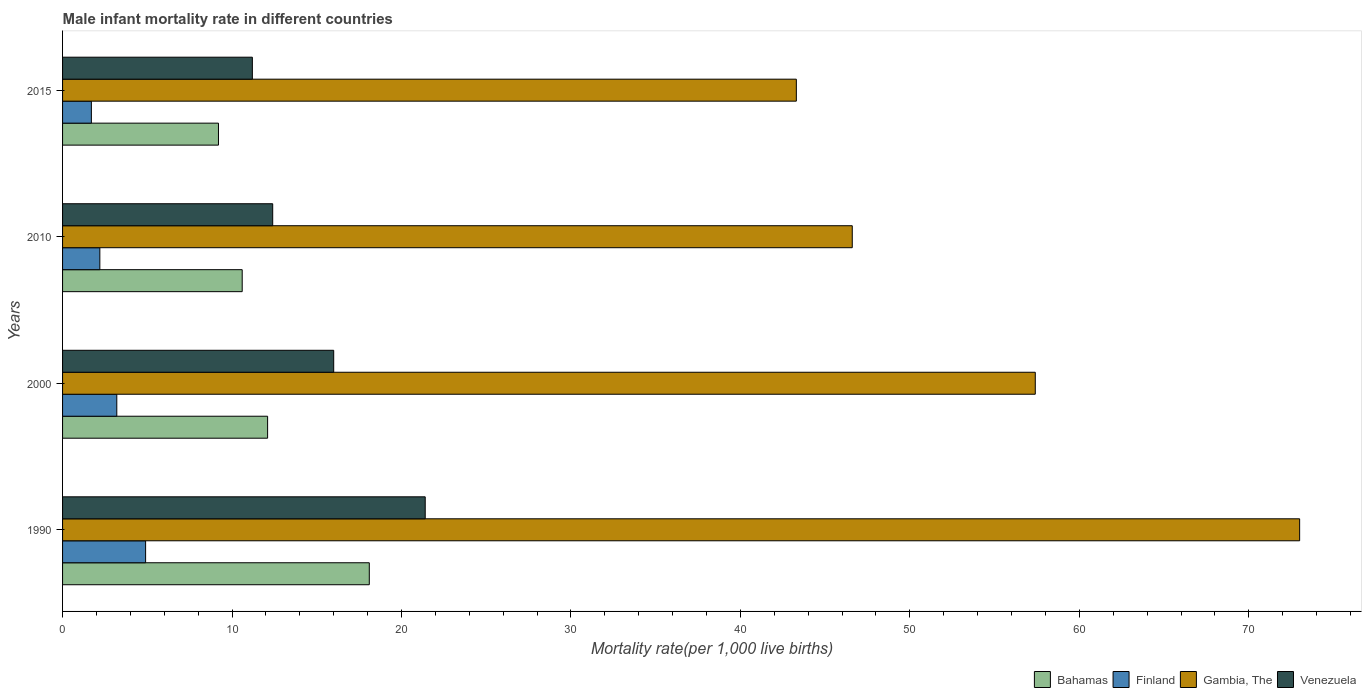Are the number of bars per tick equal to the number of legend labels?
Ensure brevity in your answer.  Yes. How many bars are there on the 2nd tick from the top?
Provide a succinct answer. 4. What is the male infant mortality rate in Gambia, The in 2010?
Provide a short and direct response. 46.6. Across all years, what is the maximum male infant mortality rate in Venezuela?
Provide a succinct answer. 21.4. Across all years, what is the minimum male infant mortality rate in Bahamas?
Offer a very short reply. 9.2. In which year was the male infant mortality rate in Gambia, The minimum?
Keep it short and to the point. 2015. What is the difference between the male infant mortality rate in Bahamas in 2010 and that in 2015?
Ensure brevity in your answer.  1.4. What is the difference between the male infant mortality rate in Bahamas in 1990 and the male infant mortality rate in Gambia, The in 2000?
Give a very brief answer. -39.3. What is the average male infant mortality rate in Gambia, The per year?
Give a very brief answer. 55.08. In the year 2010, what is the difference between the male infant mortality rate in Gambia, The and male infant mortality rate in Finland?
Offer a very short reply. 44.4. In how many years, is the male infant mortality rate in Bahamas greater than 60 ?
Offer a terse response. 0. What is the ratio of the male infant mortality rate in Bahamas in 2000 to that in 2015?
Keep it short and to the point. 1.32. Is the difference between the male infant mortality rate in Gambia, The in 2010 and 2015 greater than the difference between the male infant mortality rate in Finland in 2010 and 2015?
Provide a short and direct response. Yes. What is the difference between the highest and the second highest male infant mortality rate in Venezuela?
Make the answer very short. 5.4. Is it the case that in every year, the sum of the male infant mortality rate in Finland and male infant mortality rate in Bahamas is greater than the sum of male infant mortality rate in Gambia, The and male infant mortality rate in Venezuela?
Your answer should be very brief. Yes. What does the 3rd bar from the top in 2000 represents?
Your response must be concise. Finland. What does the 1st bar from the bottom in 2015 represents?
Offer a terse response. Bahamas. Is it the case that in every year, the sum of the male infant mortality rate in Gambia, The and male infant mortality rate in Finland is greater than the male infant mortality rate in Bahamas?
Keep it short and to the point. Yes. How many bars are there?
Make the answer very short. 16. What is the difference between two consecutive major ticks on the X-axis?
Your answer should be compact. 10. Are the values on the major ticks of X-axis written in scientific E-notation?
Your answer should be compact. No. Where does the legend appear in the graph?
Provide a succinct answer. Bottom right. How many legend labels are there?
Your answer should be very brief. 4. What is the title of the graph?
Offer a terse response. Male infant mortality rate in different countries. What is the label or title of the X-axis?
Your answer should be very brief. Mortality rate(per 1,0 live births). What is the Mortality rate(per 1,000 live births) of Bahamas in 1990?
Offer a very short reply. 18.1. What is the Mortality rate(per 1,000 live births) of Venezuela in 1990?
Your answer should be compact. 21.4. What is the Mortality rate(per 1,000 live births) in Finland in 2000?
Offer a terse response. 3.2. What is the Mortality rate(per 1,000 live births) of Gambia, The in 2000?
Provide a succinct answer. 57.4. What is the Mortality rate(per 1,000 live births) of Venezuela in 2000?
Your answer should be very brief. 16. What is the Mortality rate(per 1,000 live births) of Gambia, The in 2010?
Keep it short and to the point. 46.6. What is the Mortality rate(per 1,000 live births) of Venezuela in 2010?
Provide a short and direct response. 12.4. What is the Mortality rate(per 1,000 live births) in Bahamas in 2015?
Provide a short and direct response. 9.2. What is the Mortality rate(per 1,000 live births) of Finland in 2015?
Offer a very short reply. 1.7. What is the Mortality rate(per 1,000 live births) in Gambia, The in 2015?
Give a very brief answer. 43.3. What is the Mortality rate(per 1,000 live births) in Venezuela in 2015?
Offer a very short reply. 11.2. Across all years, what is the maximum Mortality rate(per 1,000 live births) of Bahamas?
Your answer should be very brief. 18.1. Across all years, what is the maximum Mortality rate(per 1,000 live births) of Gambia, The?
Provide a succinct answer. 73. Across all years, what is the maximum Mortality rate(per 1,000 live births) in Venezuela?
Your response must be concise. 21.4. Across all years, what is the minimum Mortality rate(per 1,000 live births) in Finland?
Provide a short and direct response. 1.7. Across all years, what is the minimum Mortality rate(per 1,000 live births) of Gambia, The?
Provide a short and direct response. 43.3. What is the total Mortality rate(per 1,000 live births) of Bahamas in the graph?
Provide a succinct answer. 50. What is the total Mortality rate(per 1,000 live births) in Gambia, The in the graph?
Give a very brief answer. 220.3. What is the difference between the Mortality rate(per 1,000 live births) of Finland in 1990 and that in 2000?
Your response must be concise. 1.7. What is the difference between the Mortality rate(per 1,000 live births) of Gambia, The in 1990 and that in 2000?
Provide a short and direct response. 15.6. What is the difference between the Mortality rate(per 1,000 live births) in Bahamas in 1990 and that in 2010?
Provide a short and direct response. 7.5. What is the difference between the Mortality rate(per 1,000 live births) of Gambia, The in 1990 and that in 2010?
Offer a terse response. 26.4. What is the difference between the Mortality rate(per 1,000 live births) of Finland in 1990 and that in 2015?
Ensure brevity in your answer.  3.2. What is the difference between the Mortality rate(per 1,000 live births) of Gambia, The in 1990 and that in 2015?
Make the answer very short. 29.7. What is the difference between the Mortality rate(per 1,000 live births) of Bahamas in 2000 and that in 2010?
Provide a succinct answer. 1.5. What is the difference between the Mortality rate(per 1,000 live births) in Finland in 2000 and that in 2010?
Offer a terse response. 1. What is the difference between the Mortality rate(per 1,000 live births) of Gambia, The in 2000 and that in 2010?
Offer a terse response. 10.8. What is the difference between the Mortality rate(per 1,000 live births) in Bahamas in 2000 and that in 2015?
Ensure brevity in your answer.  2.9. What is the difference between the Mortality rate(per 1,000 live births) of Finland in 2000 and that in 2015?
Ensure brevity in your answer.  1.5. What is the difference between the Mortality rate(per 1,000 live births) in Gambia, The in 2000 and that in 2015?
Your response must be concise. 14.1. What is the difference between the Mortality rate(per 1,000 live births) in Bahamas in 2010 and that in 2015?
Offer a very short reply. 1.4. What is the difference between the Mortality rate(per 1,000 live births) in Gambia, The in 2010 and that in 2015?
Make the answer very short. 3.3. What is the difference between the Mortality rate(per 1,000 live births) of Bahamas in 1990 and the Mortality rate(per 1,000 live births) of Gambia, The in 2000?
Offer a terse response. -39.3. What is the difference between the Mortality rate(per 1,000 live births) of Bahamas in 1990 and the Mortality rate(per 1,000 live births) of Venezuela in 2000?
Keep it short and to the point. 2.1. What is the difference between the Mortality rate(per 1,000 live births) of Finland in 1990 and the Mortality rate(per 1,000 live births) of Gambia, The in 2000?
Offer a very short reply. -52.5. What is the difference between the Mortality rate(per 1,000 live births) in Bahamas in 1990 and the Mortality rate(per 1,000 live births) in Gambia, The in 2010?
Provide a succinct answer. -28.5. What is the difference between the Mortality rate(per 1,000 live births) of Bahamas in 1990 and the Mortality rate(per 1,000 live births) of Venezuela in 2010?
Provide a short and direct response. 5.7. What is the difference between the Mortality rate(per 1,000 live births) of Finland in 1990 and the Mortality rate(per 1,000 live births) of Gambia, The in 2010?
Ensure brevity in your answer.  -41.7. What is the difference between the Mortality rate(per 1,000 live births) of Gambia, The in 1990 and the Mortality rate(per 1,000 live births) of Venezuela in 2010?
Provide a succinct answer. 60.6. What is the difference between the Mortality rate(per 1,000 live births) in Bahamas in 1990 and the Mortality rate(per 1,000 live births) in Gambia, The in 2015?
Give a very brief answer. -25.2. What is the difference between the Mortality rate(per 1,000 live births) in Finland in 1990 and the Mortality rate(per 1,000 live births) in Gambia, The in 2015?
Your response must be concise. -38.4. What is the difference between the Mortality rate(per 1,000 live births) of Finland in 1990 and the Mortality rate(per 1,000 live births) of Venezuela in 2015?
Your answer should be compact. -6.3. What is the difference between the Mortality rate(per 1,000 live births) of Gambia, The in 1990 and the Mortality rate(per 1,000 live births) of Venezuela in 2015?
Give a very brief answer. 61.8. What is the difference between the Mortality rate(per 1,000 live births) in Bahamas in 2000 and the Mortality rate(per 1,000 live births) in Finland in 2010?
Offer a very short reply. 9.9. What is the difference between the Mortality rate(per 1,000 live births) of Bahamas in 2000 and the Mortality rate(per 1,000 live births) of Gambia, The in 2010?
Offer a very short reply. -34.5. What is the difference between the Mortality rate(per 1,000 live births) of Bahamas in 2000 and the Mortality rate(per 1,000 live births) of Venezuela in 2010?
Give a very brief answer. -0.3. What is the difference between the Mortality rate(per 1,000 live births) in Finland in 2000 and the Mortality rate(per 1,000 live births) in Gambia, The in 2010?
Offer a very short reply. -43.4. What is the difference between the Mortality rate(per 1,000 live births) in Bahamas in 2000 and the Mortality rate(per 1,000 live births) in Gambia, The in 2015?
Your response must be concise. -31.2. What is the difference between the Mortality rate(per 1,000 live births) in Bahamas in 2000 and the Mortality rate(per 1,000 live births) in Venezuela in 2015?
Offer a terse response. 0.9. What is the difference between the Mortality rate(per 1,000 live births) in Finland in 2000 and the Mortality rate(per 1,000 live births) in Gambia, The in 2015?
Provide a short and direct response. -40.1. What is the difference between the Mortality rate(per 1,000 live births) of Finland in 2000 and the Mortality rate(per 1,000 live births) of Venezuela in 2015?
Give a very brief answer. -8. What is the difference between the Mortality rate(per 1,000 live births) in Gambia, The in 2000 and the Mortality rate(per 1,000 live births) in Venezuela in 2015?
Ensure brevity in your answer.  46.2. What is the difference between the Mortality rate(per 1,000 live births) of Bahamas in 2010 and the Mortality rate(per 1,000 live births) of Finland in 2015?
Your response must be concise. 8.9. What is the difference between the Mortality rate(per 1,000 live births) of Bahamas in 2010 and the Mortality rate(per 1,000 live births) of Gambia, The in 2015?
Give a very brief answer. -32.7. What is the difference between the Mortality rate(per 1,000 live births) in Finland in 2010 and the Mortality rate(per 1,000 live births) in Gambia, The in 2015?
Your answer should be compact. -41.1. What is the difference between the Mortality rate(per 1,000 live births) in Gambia, The in 2010 and the Mortality rate(per 1,000 live births) in Venezuela in 2015?
Make the answer very short. 35.4. What is the average Mortality rate(per 1,000 live births) of Bahamas per year?
Keep it short and to the point. 12.5. What is the average Mortality rate(per 1,000 live births) of Finland per year?
Keep it short and to the point. 3. What is the average Mortality rate(per 1,000 live births) in Gambia, The per year?
Your response must be concise. 55.08. What is the average Mortality rate(per 1,000 live births) in Venezuela per year?
Your answer should be very brief. 15.25. In the year 1990, what is the difference between the Mortality rate(per 1,000 live births) in Bahamas and Mortality rate(per 1,000 live births) in Finland?
Make the answer very short. 13.2. In the year 1990, what is the difference between the Mortality rate(per 1,000 live births) of Bahamas and Mortality rate(per 1,000 live births) of Gambia, The?
Provide a short and direct response. -54.9. In the year 1990, what is the difference between the Mortality rate(per 1,000 live births) in Finland and Mortality rate(per 1,000 live births) in Gambia, The?
Keep it short and to the point. -68.1. In the year 1990, what is the difference between the Mortality rate(per 1,000 live births) of Finland and Mortality rate(per 1,000 live births) of Venezuela?
Your answer should be compact. -16.5. In the year 1990, what is the difference between the Mortality rate(per 1,000 live births) in Gambia, The and Mortality rate(per 1,000 live births) in Venezuela?
Keep it short and to the point. 51.6. In the year 2000, what is the difference between the Mortality rate(per 1,000 live births) of Bahamas and Mortality rate(per 1,000 live births) of Finland?
Offer a terse response. 8.9. In the year 2000, what is the difference between the Mortality rate(per 1,000 live births) of Bahamas and Mortality rate(per 1,000 live births) of Gambia, The?
Offer a terse response. -45.3. In the year 2000, what is the difference between the Mortality rate(per 1,000 live births) in Finland and Mortality rate(per 1,000 live births) in Gambia, The?
Offer a terse response. -54.2. In the year 2000, what is the difference between the Mortality rate(per 1,000 live births) of Gambia, The and Mortality rate(per 1,000 live births) of Venezuela?
Provide a succinct answer. 41.4. In the year 2010, what is the difference between the Mortality rate(per 1,000 live births) of Bahamas and Mortality rate(per 1,000 live births) of Finland?
Give a very brief answer. 8.4. In the year 2010, what is the difference between the Mortality rate(per 1,000 live births) in Bahamas and Mortality rate(per 1,000 live births) in Gambia, The?
Give a very brief answer. -36. In the year 2010, what is the difference between the Mortality rate(per 1,000 live births) in Bahamas and Mortality rate(per 1,000 live births) in Venezuela?
Provide a succinct answer. -1.8. In the year 2010, what is the difference between the Mortality rate(per 1,000 live births) in Finland and Mortality rate(per 1,000 live births) in Gambia, The?
Your answer should be compact. -44.4. In the year 2010, what is the difference between the Mortality rate(per 1,000 live births) in Finland and Mortality rate(per 1,000 live births) in Venezuela?
Your answer should be compact. -10.2. In the year 2010, what is the difference between the Mortality rate(per 1,000 live births) of Gambia, The and Mortality rate(per 1,000 live births) of Venezuela?
Offer a very short reply. 34.2. In the year 2015, what is the difference between the Mortality rate(per 1,000 live births) of Bahamas and Mortality rate(per 1,000 live births) of Finland?
Offer a terse response. 7.5. In the year 2015, what is the difference between the Mortality rate(per 1,000 live births) of Bahamas and Mortality rate(per 1,000 live births) of Gambia, The?
Make the answer very short. -34.1. In the year 2015, what is the difference between the Mortality rate(per 1,000 live births) of Finland and Mortality rate(per 1,000 live births) of Gambia, The?
Make the answer very short. -41.6. In the year 2015, what is the difference between the Mortality rate(per 1,000 live births) in Gambia, The and Mortality rate(per 1,000 live births) in Venezuela?
Your response must be concise. 32.1. What is the ratio of the Mortality rate(per 1,000 live births) of Bahamas in 1990 to that in 2000?
Your answer should be very brief. 1.5. What is the ratio of the Mortality rate(per 1,000 live births) of Finland in 1990 to that in 2000?
Provide a short and direct response. 1.53. What is the ratio of the Mortality rate(per 1,000 live births) of Gambia, The in 1990 to that in 2000?
Keep it short and to the point. 1.27. What is the ratio of the Mortality rate(per 1,000 live births) of Venezuela in 1990 to that in 2000?
Give a very brief answer. 1.34. What is the ratio of the Mortality rate(per 1,000 live births) of Bahamas in 1990 to that in 2010?
Offer a very short reply. 1.71. What is the ratio of the Mortality rate(per 1,000 live births) of Finland in 1990 to that in 2010?
Provide a short and direct response. 2.23. What is the ratio of the Mortality rate(per 1,000 live births) in Gambia, The in 1990 to that in 2010?
Offer a very short reply. 1.57. What is the ratio of the Mortality rate(per 1,000 live births) of Venezuela in 1990 to that in 2010?
Your answer should be very brief. 1.73. What is the ratio of the Mortality rate(per 1,000 live births) in Bahamas in 1990 to that in 2015?
Provide a succinct answer. 1.97. What is the ratio of the Mortality rate(per 1,000 live births) of Finland in 1990 to that in 2015?
Ensure brevity in your answer.  2.88. What is the ratio of the Mortality rate(per 1,000 live births) of Gambia, The in 1990 to that in 2015?
Provide a short and direct response. 1.69. What is the ratio of the Mortality rate(per 1,000 live births) in Venezuela in 1990 to that in 2015?
Offer a very short reply. 1.91. What is the ratio of the Mortality rate(per 1,000 live births) in Bahamas in 2000 to that in 2010?
Your answer should be compact. 1.14. What is the ratio of the Mortality rate(per 1,000 live births) in Finland in 2000 to that in 2010?
Give a very brief answer. 1.45. What is the ratio of the Mortality rate(per 1,000 live births) of Gambia, The in 2000 to that in 2010?
Your answer should be compact. 1.23. What is the ratio of the Mortality rate(per 1,000 live births) in Venezuela in 2000 to that in 2010?
Provide a succinct answer. 1.29. What is the ratio of the Mortality rate(per 1,000 live births) in Bahamas in 2000 to that in 2015?
Your answer should be compact. 1.32. What is the ratio of the Mortality rate(per 1,000 live births) in Finland in 2000 to that in 2015?
Your response must be concise. 1.88. What is the ratio of the Mortality rate(per 1,000 live births) of Gambia, The in 2000 to that in 2015?
Offer a very short reply. 1.33. What is the ratio of the Mortality rate(per 1,000 live births) in Venezuela in 2000 to that in 2015?
Provide a short and direct response. 1.43. What is the ratio of the Mortality rate(per 1,000 live births) in Bahamas in 2010 to that in 2015?
Offer a very short reply. 1.15. What is the ratio of the Mortality rate(per 1,000 live births) of Finland in 2010 to that in 2015?
Offer a very short reply. 1.29. What is the ratio of the Mortality rate(per 1,000 live births) of Gambia, The in 2010 to that in 2015?
Your response must be concise. 1.08. What is the ratio of the Mortality rate(per 1,000 live births) in Venezuela in 2010 to that in 2015?
Your answer should be very brief. 1.11. What is the difference between the highest and the second highest Mortality rate(per 1,000 live births) in Bahamas?
Your response must be concise. 6. What is the difference between the highest and the second highest Mortality rate(per 1,000 live births) in Finland?
Offer a terse response. 1.7. What is the difference between the highest and the second highest Mortality rate(per 1,000 live births) in Gambia, The?
Your answer should be compact. 15.6. What is the difference between the highest and the lowest Mortality rate(per 1,000 live births) of Finland?
Your answer should be very brief. 3.2. What is the difference between the highest and the lowest Mortality rate(per 1,000 live births) in Gambia, The?
Give a very brief answer. 29.7. 